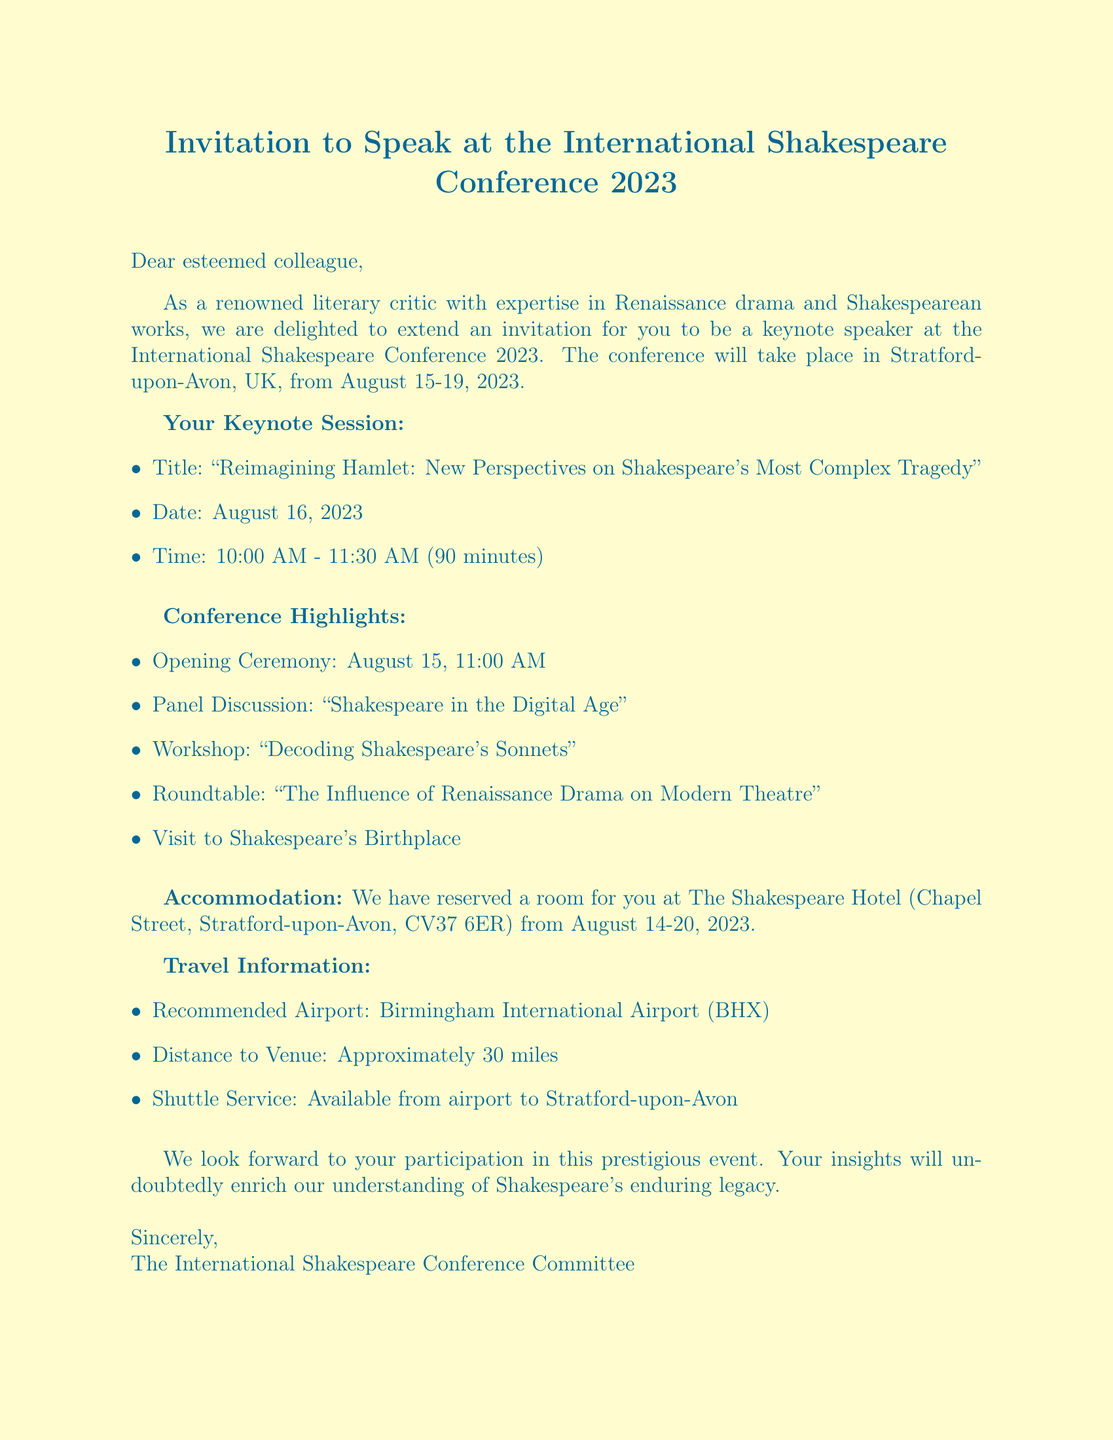what is the name of the conference? The document specifies that the event is called the International Shakespeare Conference 2023.
Answer: International Shakespeare Conference 2023 where is the conference located? The location of the conference is stated in the document as Stratford-upon-Avon, UK.
Answer: Stratford-upon-Avon, UK when does the keynote session take place? The document lists the date of the keynote session as August 16, 2023.
Answer: August 16, 2023 how long is the keynote speech? The duration detailed in the document indicates that the keynote speech lasts for 90 minutes.
Answer: 90 minutes what is one of the notable sessions listed in the document? The document provides several notable session titles, one being “Women in Shakespeare: Challenging Traditional Interpretations.”
Answer: Women in Shakespeare: Challenging Traditional Interpretations what type of accommodation is provided? The document mentions that accommodation is reserved at The Shakespeare Hotel.
Answer: The Shakespeare Hotel how far is the recommended airport from the venue? The document states that the distance from the airport to the venue is approximately 30 miles.
Answer: Approximately 30 miles what day has the opening ceremony? According to the itinerary in the document, the opening ceremony takes place on August 15, 2023.
Answer: August 15, 2023 what is the time for the workshop on August 16? The document specifies the workshop takes place at 3:00 PM on August 16, 2023.
Answer: 3:00 PM 